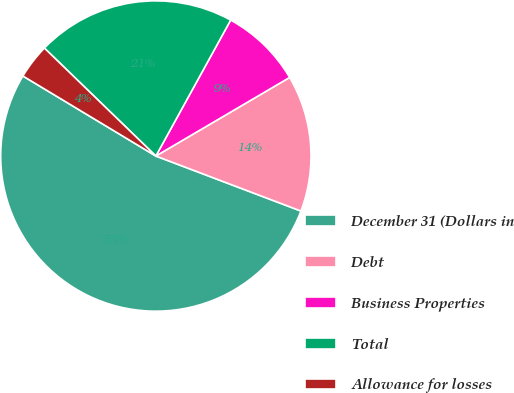<chart> <loc_0><loc_0><loc_500><loc_500><pie_chart><fcel>December 31 (Dollars in<fcel>Debt<fcel>Business Properties<fcel>Total<fcel>Allowance for losses<nl><fcel>52.85%<fcel>14.22%<fcel>8.54%<fcel>20.76%<fcel>3.62%<nl></chart> 